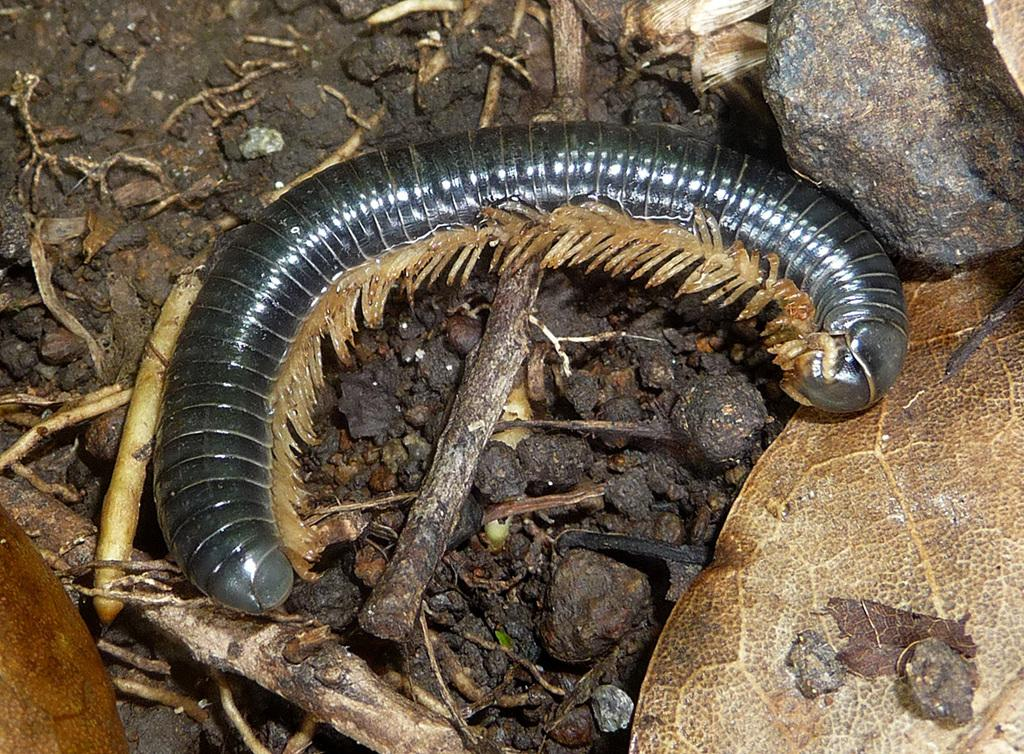What is present on the surface of the sand in the image? There is an insect on the surface of the sand. What other objects or elements can be seen in the image? There are dry leaves in the image. What type of request can be seen in the image? There is no request present in the image; it features an insect on the sand and dry leaves. Can you show me the clam in the image? There is no clam present in the image. 